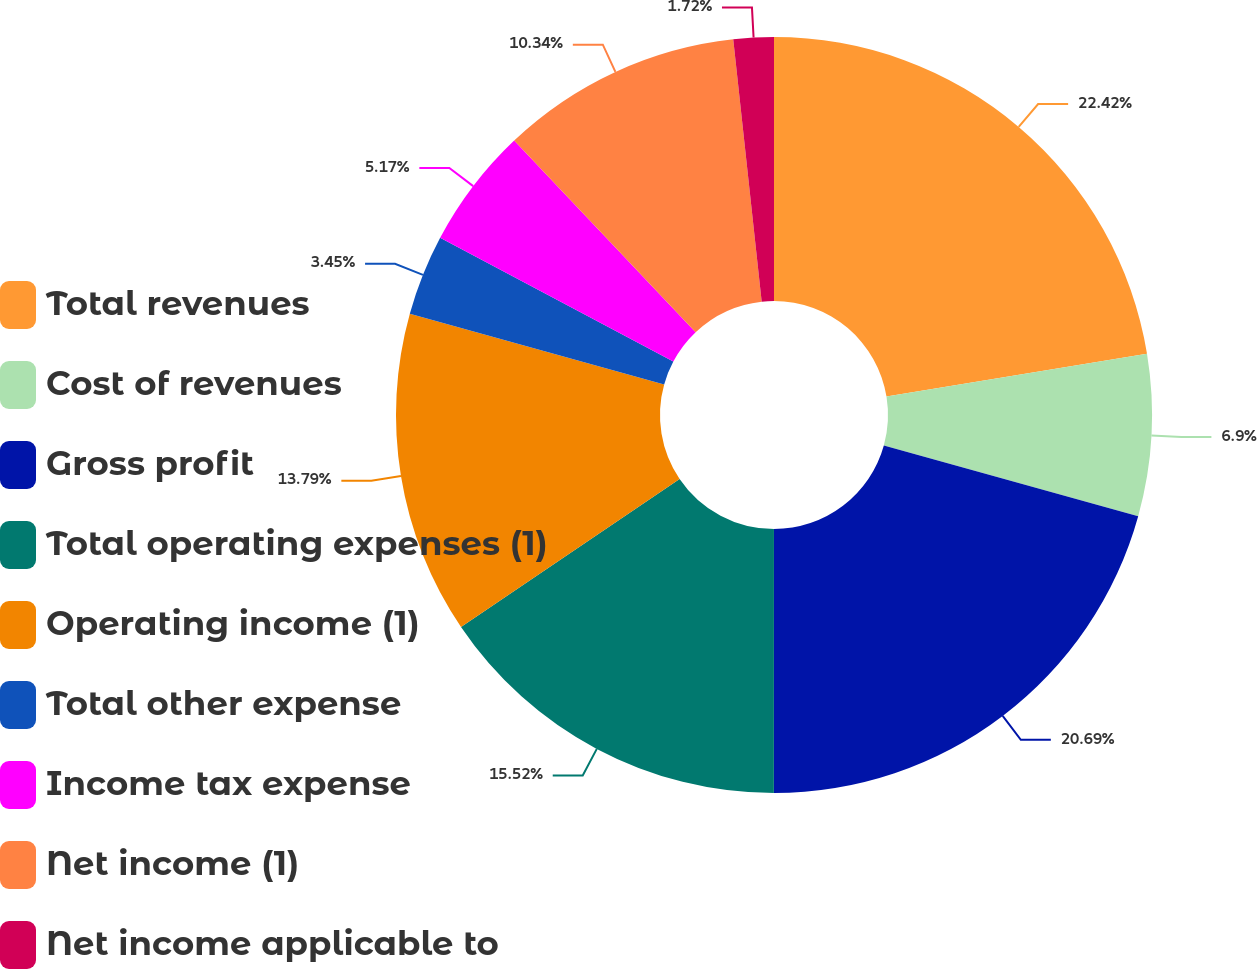Convert chart. <chart><loc_0><loc_0><loc_500><loc_500><pie_chart><fcel>Total revenues<fcel>Cost of revenues<fcel>Gross profit<fcel>Total operating expenses (1)<fcel>Operating income (1)<fcel>Total other expense<fcel>Income tax expense<fcel>Net income (1)<fcel>Net income applicable to<nl><fcel>22.41%<fcel>6.9%<fcel>20.69%<fcel>15.52%<fcel>13.79%<fcel>3.45%<fcel>5.17%<fcel>10.34%<fcel>1.72%<nl></chart> 